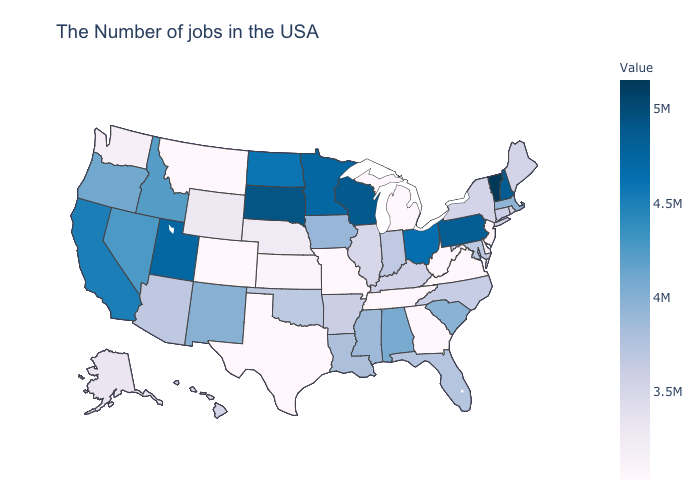Does the map have missing data?
Concise answer only. No. Is the legend a continuous bar?
Short answer required. Yes. Among the states that border Wisconsin , which have the highest value?
Short answer required. Minnesota. 